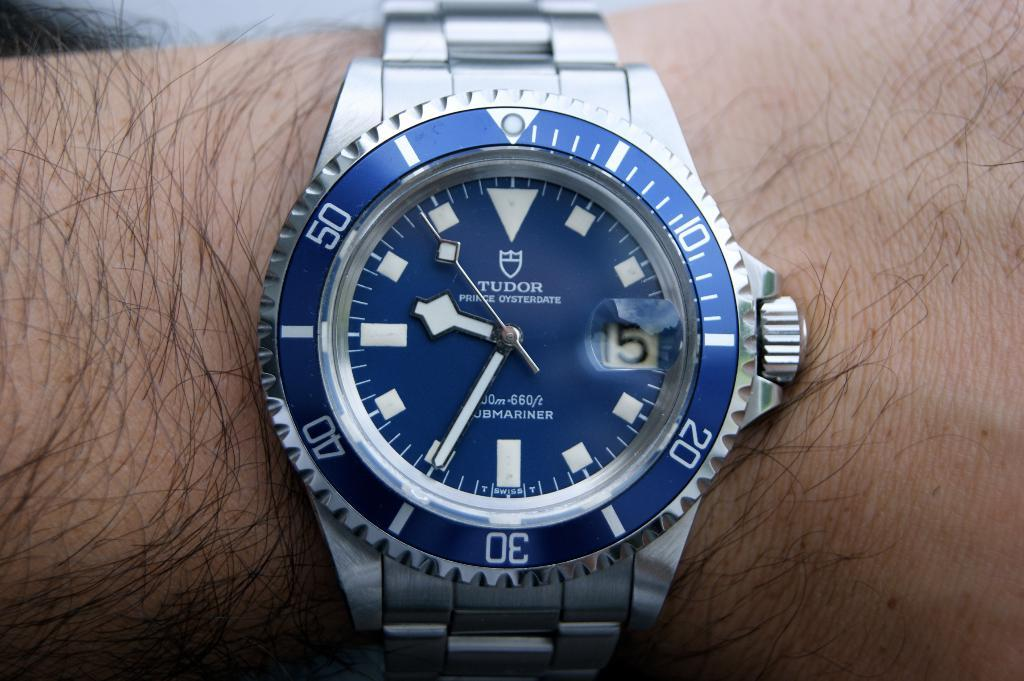<image>
Summarize the visual content of the image. a tudor prince oysterdate watch with a silver band 